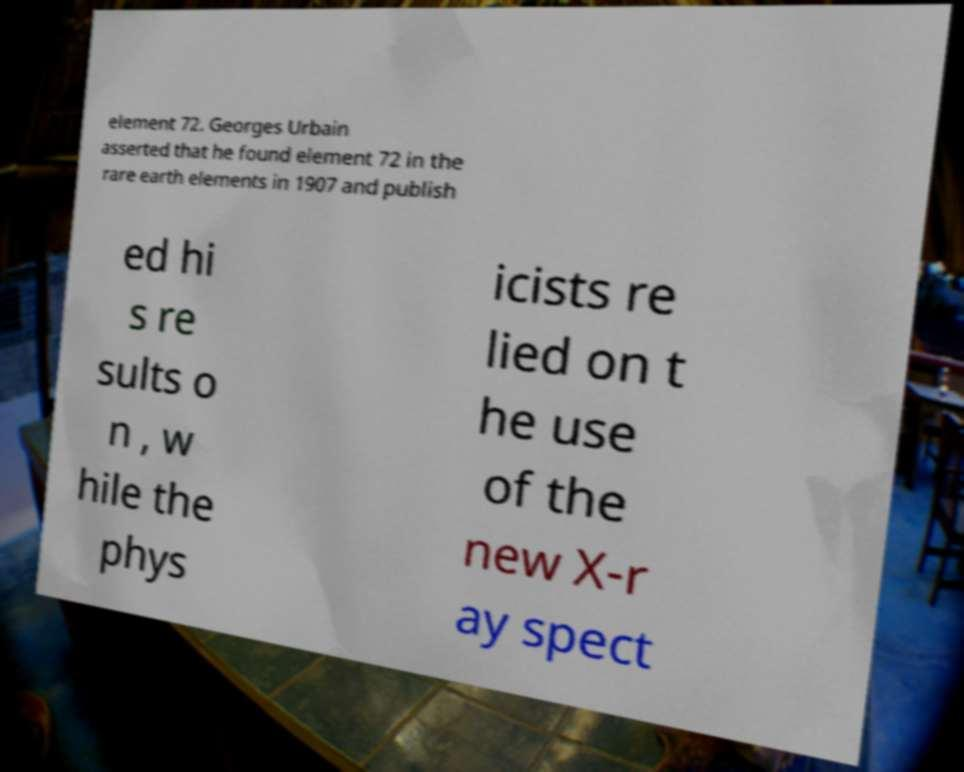Please read and relay the text visible in this image. What does it say? element 72. Georges Urbain asserted that he found element 72 in the rare earth elements in 1907 and publish ed hi s re sults o n , w hile the phys icists re lied on t he use of the new X-r ay spect 